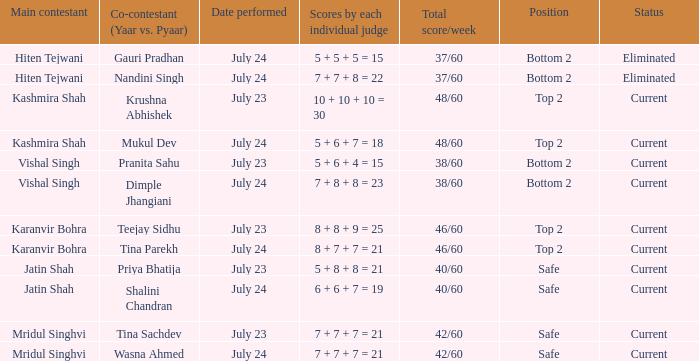I'm looking to parse the entire table for insights. Could you assist me with that? {'header': ['Main contestant', 'Co-contestant (Yaar vs. Pyaar)', 'Date performed', 'Scores by each individual judge', 'Total score/week', 'Position', 'Status'], 'rows': [['Hiten Tejwani', 'Gauri Pradhan', 'July 24', '5 + 5 + 5 = 15', '37/60', 'Bottom 2', 'Eliminated'], ['Hiten Tejwani', 'Nandini Singh', 'July 24', '7 + 7 + 8 = 22', '37/60', 'Bottom 2', 'Eliminated'], ['Kashmira Shah', 'Krushna Abhishek', 'July 23', '10 + 10 + 10 = 30', '48/60', 'Top 2', 'Current'], ['Kashmira Shah', 'Mukul Dev', 'July 24', '5 + 6 + 7 = 18', '48/60', 'Top 2', 'Current'], ['Vishal Singh', 'Pranita Sahu', 'July 23', '5 + 6 + 4 = 15', '38/60', 'Bottom 2', 'Current'], ['Vishal Singh', 'Dimple Jhangiani', 'July 24', '7 + 8 + 8 = 23', '38/60', 'Bottom 2', 'Current'], ['Karanvir Bohra', 'Teejay Sidhu', 'July 23', '8 + 8 + 9 = 25', '46/60', 'Top 2', 'Current'], ['Karanvir Bohra', 'Tina Parekh', 'July 24', '8 + 7 + 7 = 21', '46/60', 'Top 2', 'Current'], ['Jatin Shah', 'Priya Bhatija', 'July 23', '5 + 8 + 8 = 21', '40/60', 'Safe', 'Current'], ['Jatin Shah', 'Shalini Chandran', 'July 24', '6 + 6 + 7 = 19', '40/60', 'Safe', 'Current'], ['Mridul Singhvi', 'Tina Sachdev', 'July 23', '7 + 7 + 7 = 21', '42/60', 'Safe', 'Current'], ['Mridul Singhvi', 'Wasna Ahmed', 'July 24', '7 + 7 + 7 = 21', '42/60', 'Safe', 'Current']]} In yaar vs. pyaa, who has a weekly total score of 42/60 and is partnered with tina sachdev as their co-contestant? Mridul Singhvi. 